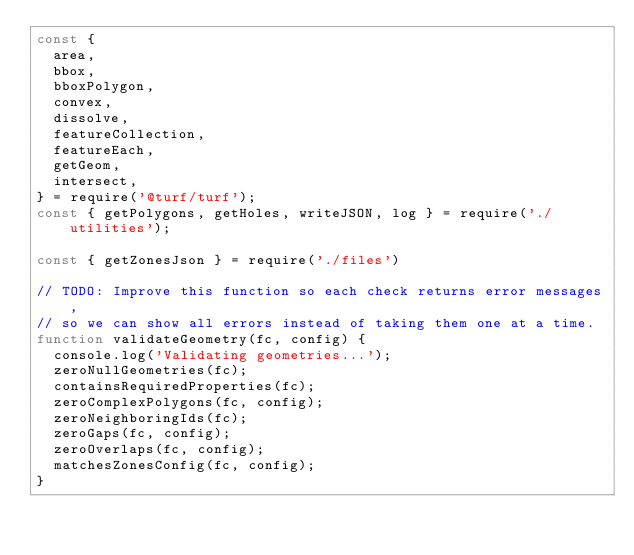Convert code to text. <code><loc_0><loc_0><loc_500><loc_500><_JavaScript_>const {
  area,
  bbox,
  bboxPolygon,
  convex,
  dissolve,
  featureCollection,
  featureEach,
  getGeom,
  intersect,
} = require('@turf/turf');
const { getPolygons, getHoles, writeJSON, log } = require('./utilities');

const { getZonesJson } = require('./files')

// TODO: Improve this function so each check returns error messages,
// so we can show all errors instead of taking them one at a time.
function validateGeometry(fc, config) {
  console.log('Validating geometries...');
  zeroNullGeometries(fc);
  containsRequiredProperties(fc);
  zeroComplexPolygons(fc, config);
  zeroNeighboringIds(fc);
  zeroGaps(fc, config);
  zeroOverlaps(fc, config);
  matchesZonesConfig(fc, config);
}
</code> 